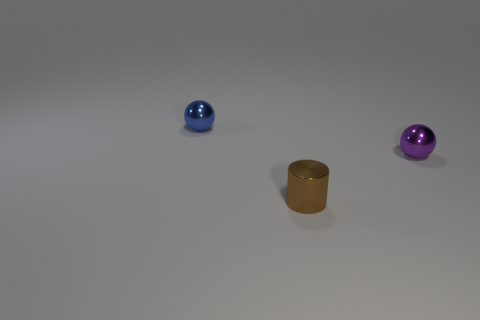How many objects are either shiny cylinders or blue objects?
Provide a succinct answer. 2. There is a blue metal thing; are there any tiny things to the right of it?
Offer a terse response. Yes. Are there any brown things that have the same material as the tiny brown cylinder?
Make the answer very short. No. What number of cylinders are tiny purple metallic objects or tiny blue shiny objects?
Provide a succinct answer. 0. Is the number of small brown objects left of the tiny purple sphere greater than the number of small brown cylinders right of the brown object?
Offer a very short reply. Yes. What number of other cylinders are the same color as the small metallic cylinder?
Your response must be concise. 0. The brown cylinder that is the same material as the blue thing is what size?
Provide a succinct answer. Small. What number of objects are either small metallic balls in front of the blue ball or shiny balls?
Your answer should be very brief. 2. What size is the blue thing that is the same shape as the small purple metallic object?
Offer a very short reply. Small. What is the color of the shiny sphere that is behind the tiny sphere right of the ball that is to the left of the tiny purple metallic sphere?
Provide a short and direct response. Blue. 